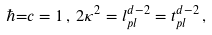Convert formula to latex. <formula><loc_0><loc_0><loc_500><loc_500>\hbar { = } c = 1 \, , \, 2 \kappa ^ { 2 } = l _ { p l } ^ { d - 2 } = t _ { p l } ^ { d - 2 } \, ,</formula> 